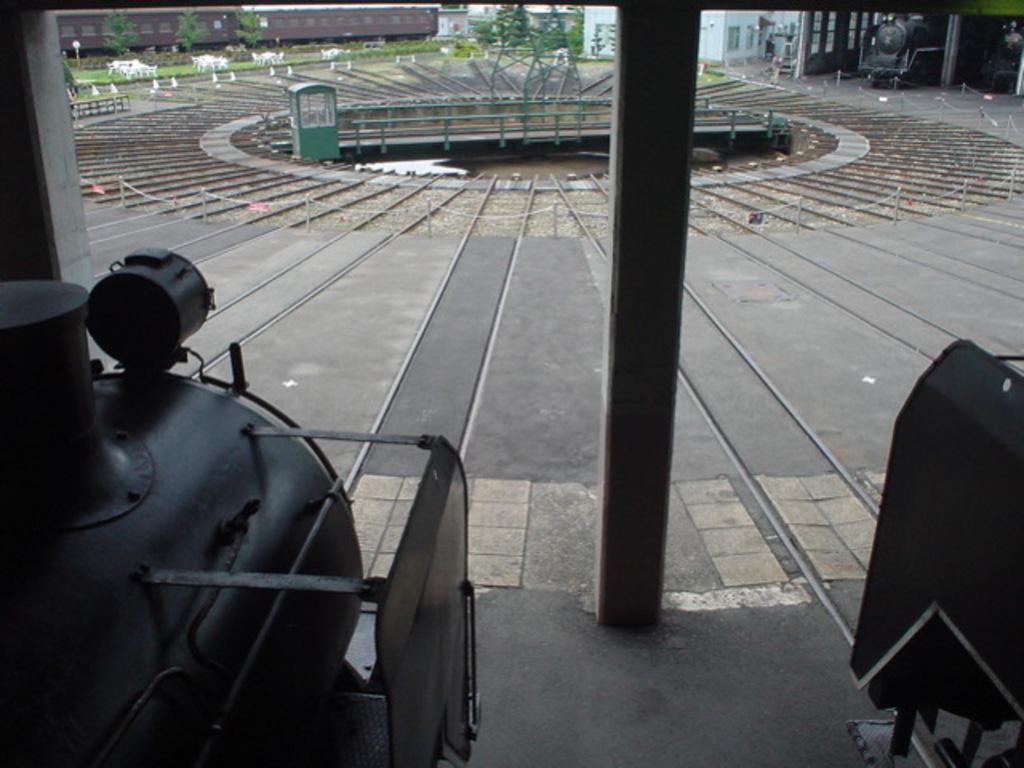Describe this image in one or two sentences. In the image we can see the steam engines on the track. There are pillars and there are tables, and benches. We can even see there is a train and buildings. This is a grass and trees. 